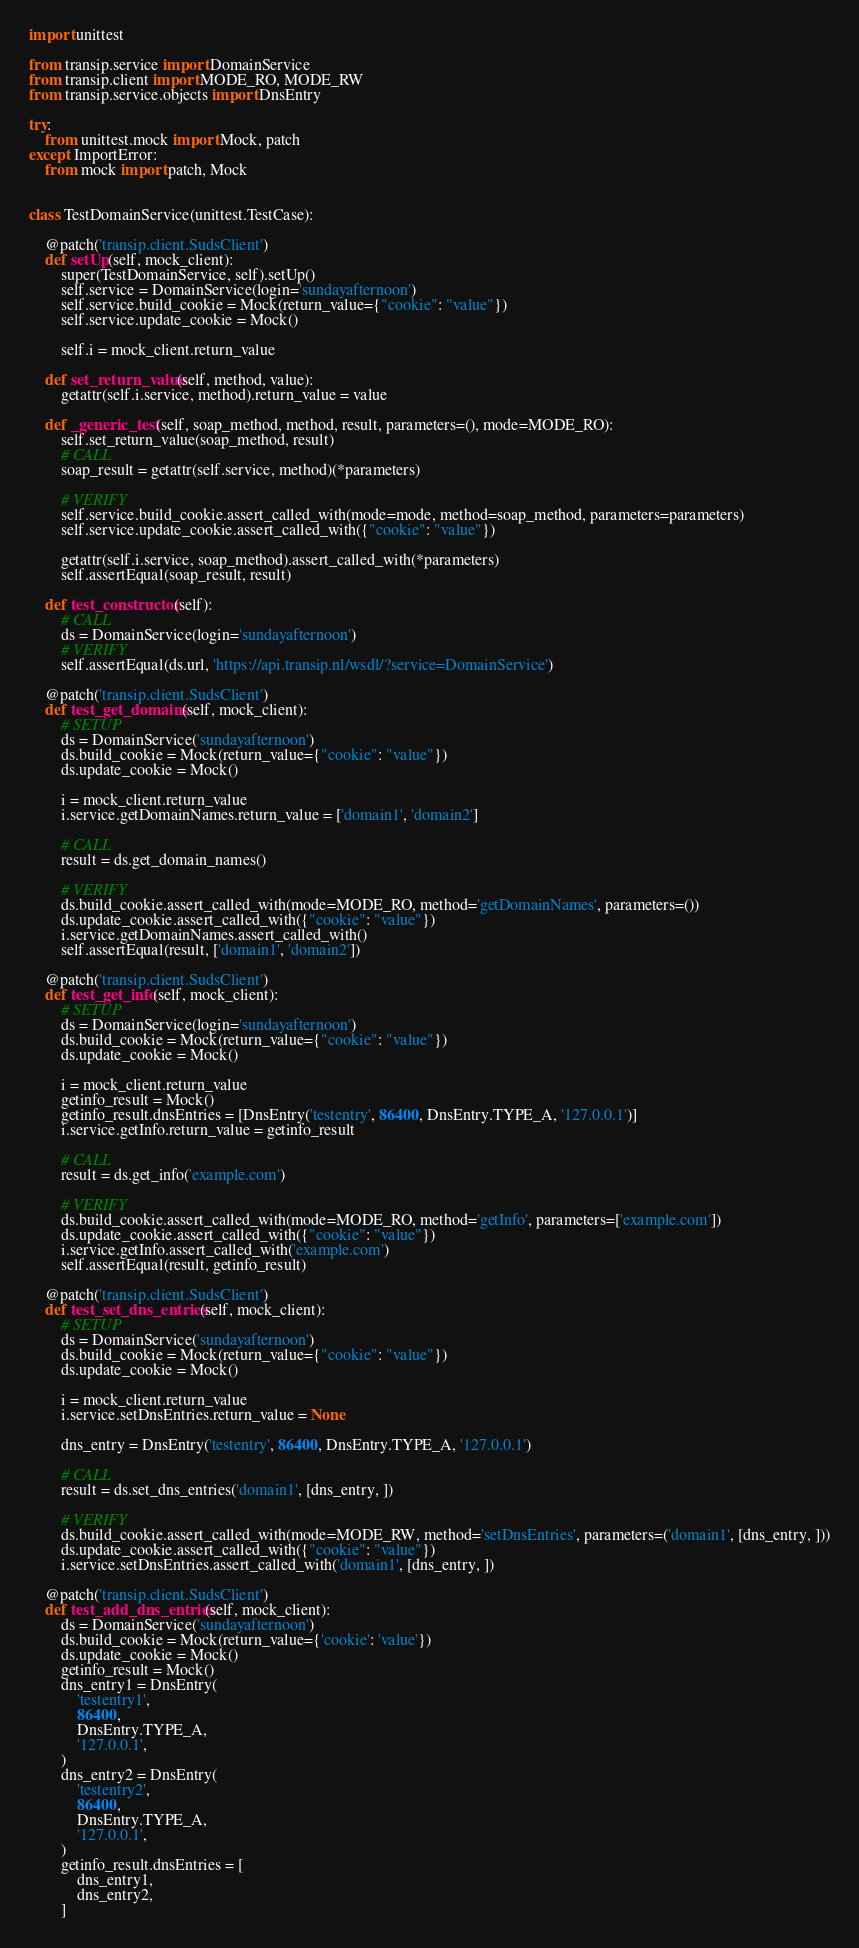Convert code to text. <code><loc_0><loc_0><loc_500><loc_500><_Python_>import unittest

from transip.service import DomainService
from transip.client import MODE_RO, MODE_RW
from transip.service.objects import DnsEntry

try:
    from unittest.mock import Mock, patch
except ImportError:
    from mock import patch, Mock


class TestDomainService(unittest.TestCase):

    @patch('transip.client.SudsClient')
    def setUp(self, mock_client):
        super(TestDomainService, self).setUp()
        self.service = DomainService(login='sundayafternoon')
        self.service.build_cookie = Mock(return_value={"cookie": "value"})
        self.service.update_cookie = Mock()

        self.i = mock_client.return_value

    def set_return_value(self, method, value):
        getattr(self.i.service, method).return_value = value

    def _generic_test(self, soap_method, method, result, parameters=(), mode=MODE_RO):
        self.set_return_value(soap_method, result)
        # CALL
        soap_result = getattr(self.service, method)(*parameters)

        # VERIFY
        self.service.build_cookie.assert_called_with(mode=mode, method=soap_method, parameters=parameters)
        self.service.update_cookie.assert_called_with({"cookie": "value"})

        getattr(self.i.service, soap_method).assert_called_with(*parameters)
        self.assertEqual(soap_result, result)

    def test_constructor(self):
        # CALL
        ds = DomainService(login='sundayafternoon')
        # VERIFY
        self.assertEqual(ds.url, 'https://api.transip.nl/wsdl/?service=DomainService')

    @patch('transip.client.SudsClient')
    def test_get_domains(self, mock_client):
        # SETUP
        ds = DomainService('sundayafternoon')
        ds.build_cookie = Mock(return_value={"cookie": "value"})
        ds.update_cookie = Mock()

        i = mock_client.return_value
        i.service.getDomainNames.return_value = ['domain1', 'domain2']

        # CALL
        result = ds.get_domain_names()

        # VERIFY
        ds.build_cookie.assert_called_with(mode=MODE_RO, method='getDomainNames', parameters=())
        ds.update_cookie.assert_called_with({"cookie": "value"})
        i.service.getDomainNames.assert_called_with()
        self.assertEqual(result, ['domain1', 'domain2'])

    @patch('transip.client.SudsClient')
    def test_get_info(self, mock_client):
        # SETUP
        ds = DomainService(login='sundayafternoon')
        ds.build_cookie = Mock(return_value={"cookie": "value"})
        ds.update_cookie = Mock()

        i = mock_client.return_value
        getinfo_result = Mock()
        getinfo_result.dnsEntries = [DnsEntry('testentry', 86400, DnsEntry.TYPE_A, '127.0.0.1')]
        i.service.getInfo.return_value = getinfo_result

        # CALL
        result = ds.get_info('example.com')

        # VERIFY
        ds.build_cookie.assert_called_with(mode=MODE_RO, method='getInfo', parameters=['example.com'])
        ds.update_cookie.assert_called_with({"cookie": "value"})
        i.service.getInfo.assert_called_with('example.com')
        self.assertEqual(result, getinfo_result)

    @patch('transip.client.SudsClient')
    def test_set_dns_entries(self, mock_client):
        # SETUP
        ds = DomainService('sundayafternoon')
        ds.build_cookie = Mock(return_value={"cookie": "value"})
        ds.update_cookie = Mock()

        i = mock_client.return_value
        i.service.setDnsEntries.return_value = None

        dns_entry = DnsEntry('testentry', 86400, DnsEntry.TYPE_A, '127.0.0.1')

        # CALL
        result = ds.set_dns_entries('domain1', [dns_entry, ])

        # VERIFY
        ds.build_cookie.assert_called_with(mode=MODE_RW, method='setDnsEntries', parameters=('domain1', [dns_entry, ]))
        ds.update_cookie.assert_called_with({"cookie": "value"})
        i.service.setDnsEntries.assert_called_with('domain1', [dns_entry, ])

    @patch('transip.client.SudsClient')
    def test_add_dns_entries(self, mock_client):
        ds = DomainService('sundayafternoon')
        ds.build_cookie = Mock(return_value={'cookie': 'value'})
        ds.update_cookie = Mock()
        getinfo_result = Mock()
        dns_entry1 = DnsEntry(
            'testentry1',
            86400,
            DnsEntry.TYPE_A,
            '127.0.0.1',
        )
        dns_entry2 = DnsEntry(
            'testentry2',
            86400,
            DnsEntry.TYPE_A,
            '127.0.0.1',
        )
        getinfo_result.dnsEntries = [
            dns_entry1,
            dns_entry2,
        ]</code> 